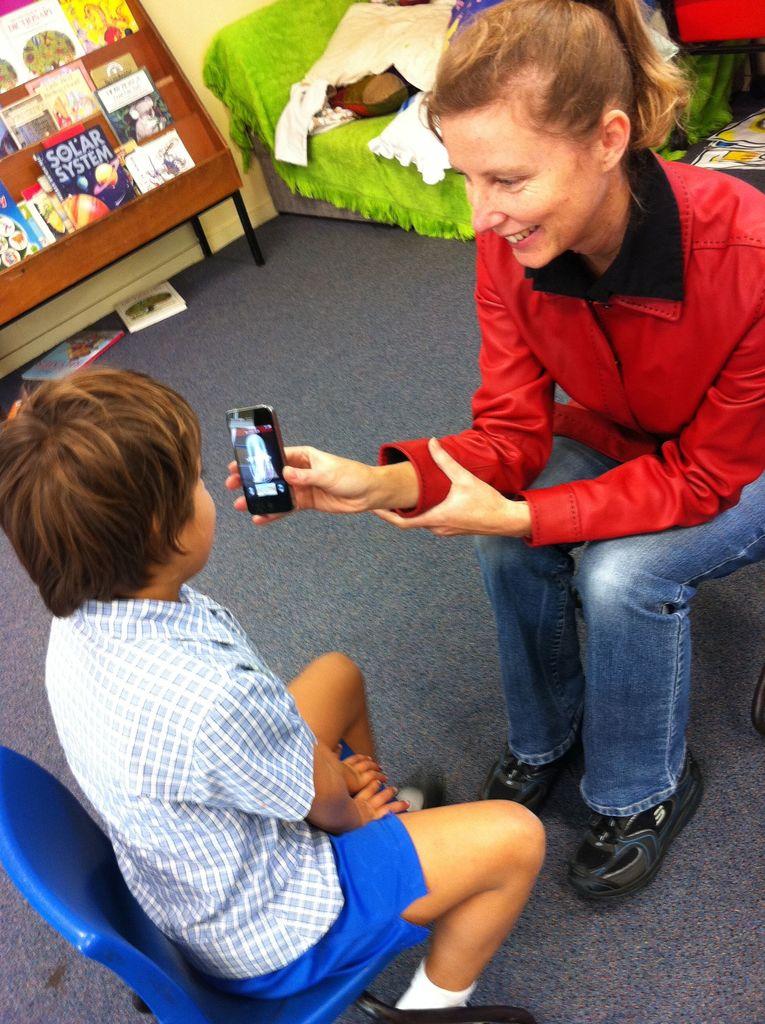What type of system is described in the book on the bottom shelf?
Offer a terse response. Solar system. What is the blue book on the back shelf about?
Keep it short and to the point. Solar system. 